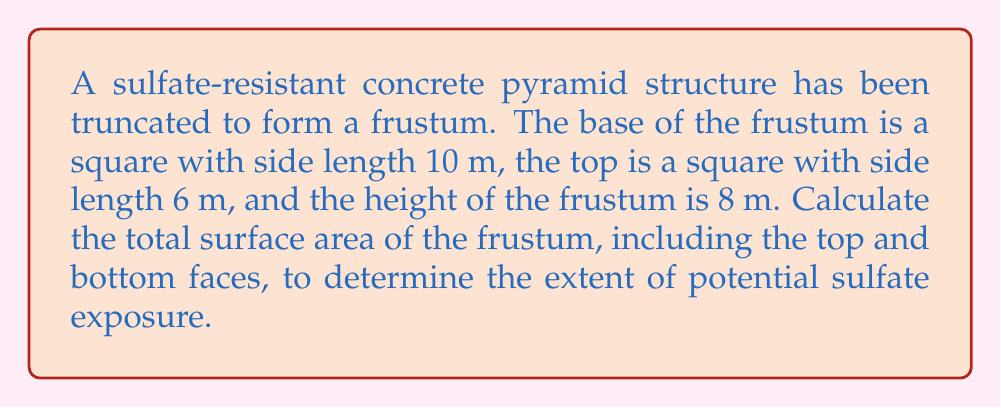Help me with this question. To calculate the surface area of the truncated pyramid (frustum), we need to find:
1. Area of the base
2. Area of the top
3. Area of the slant surfaces

Step 1: Calculate the area of the base and top
Base area: $A_b = 10^2 = 100$ m²
Top area: $A_t = 6^2 = 36$ m²

Step 2: Find the slant height
Let's use the Pythagorean theorem to find the slant height (l):
$$l^2 = (\frac{10-6}{2})^2 + 8^2$$
$$l^2 = 2^2 + 8^2 = 4 + 64 = 68$$
$$l = \sqrt{68} \approx 8.246$ m

Step 3: Calculate the area of one trapezoidal face
Area of trapezoid = $\frac{a+b}{2}h$, where a and b are parallel sides and h is the height
$$A_{trapezoid} = \frac{10+6}{2} \cdot 8.246 = 8 \cdot 8.246 = 65.968$ m²

Step 4: Calculate the total surface area
Total surface area = Base area + Top area + (4 × Trapezoidal face area)
$$A_{total} = 100 + 36 + (4 \cdot 65.968)$$
$$A_{total} = 136 + 263.872 = 399.872$ m²

[asy]
import three;

size(200);
currentprojection=perspective(6,3,2);

triple A=(0,0,0), B=(10,0,0), C=(10,10,0), D=(0,10,0);
triple E=(2,2,8), F=(8,2,8), G=(8,8,8), H=(2,8,8);

draw(A--B--C--D--cycle);
draw(E--F--G--H--cycle);
draw(A--E);
draw(B--F);
draw(C--G);
draw(D--H);

label("10m", (A+B)/2, S);
label("10m", (B+C)/2, E);
label("6m", (E+F)/2, N);
label("6m", (F+G)/2, E);
label("8m", (A+E)/2, W);
[/asy]
Answer: 399.872 m² 